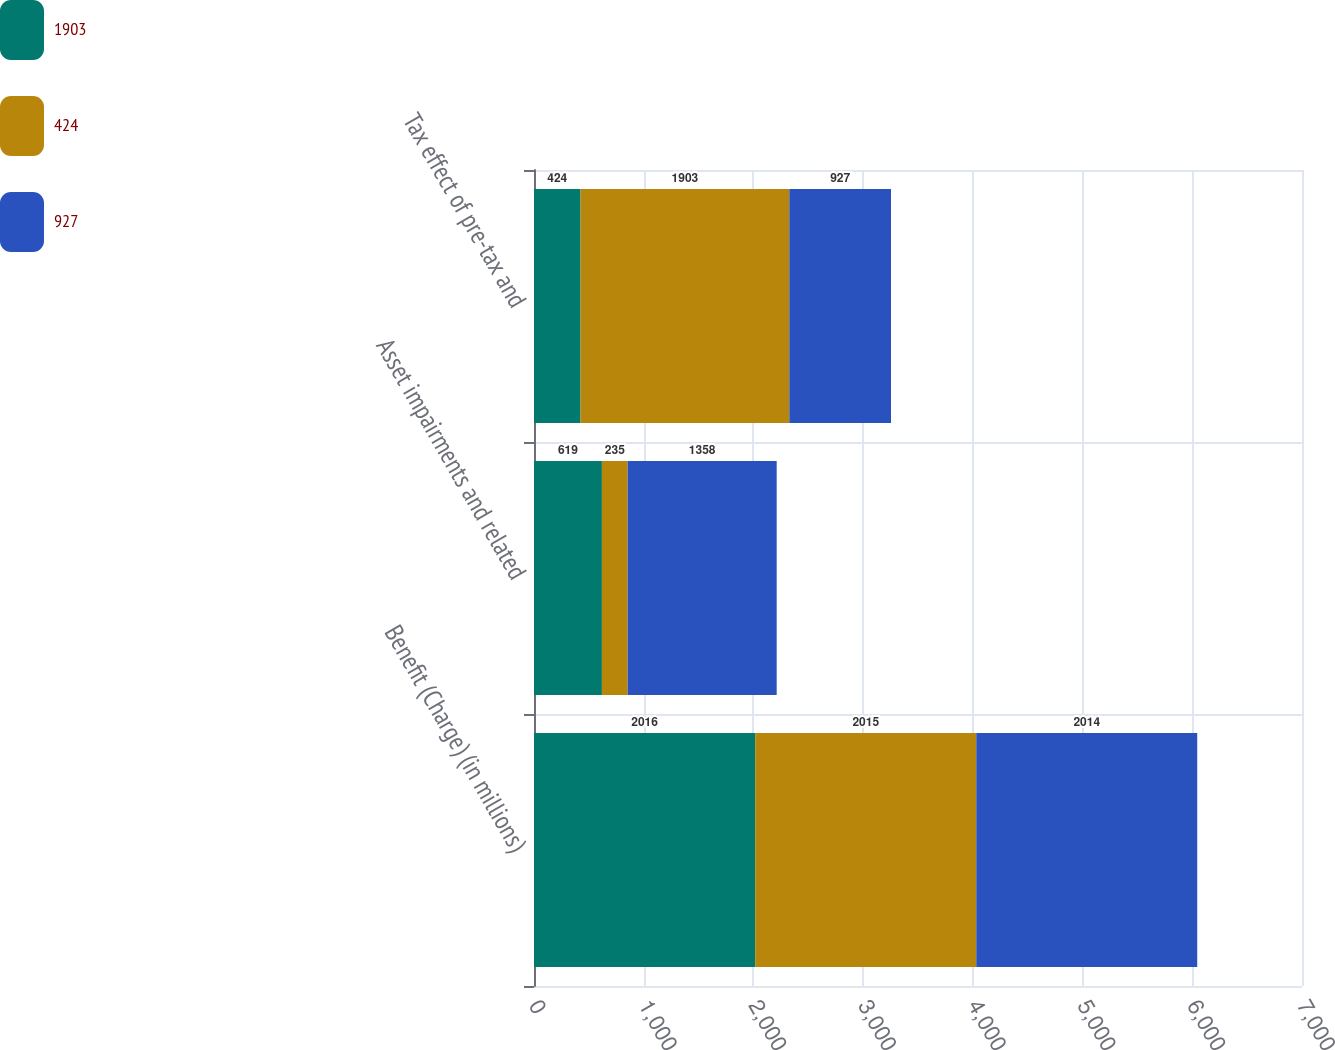Convert chart to OTSL. <chart><loc_0><loc_0><loc_500><loc_500><stacked_bar_chart><ecel><fcel>Benefit (Charge) (in millions)<fcel>Asset impairments and related<fcel>Tax effect of pre-tax and<nl><fcel>1903<fcel>2016<fcel>619<fcel>424<nl><fcel>424<fcel>2015<fcel>235<fcel>1903<nl><fcel>927<fcel>2014<fcel>1358<fcel>927<nl></chart> 